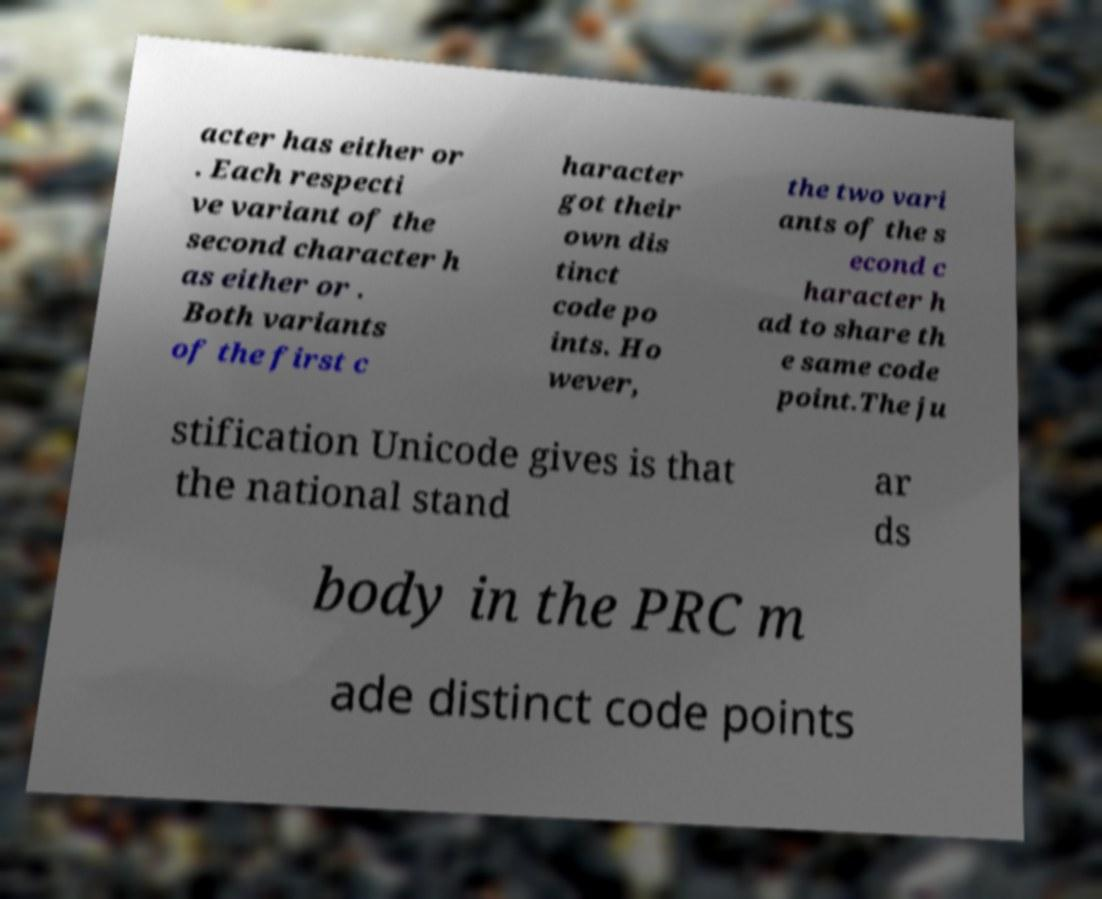Could you assist in decoding the text presented in this image and type it out clearly? acter has either or . Each respecti ve variant of the second character h as either or . Both variants of the first c haracter got their own dis tinct code po ints. Ho wever, the two vari ants of the s econd c haracter h ad to share th e same code point.The ju stification Unicode gives is that the national stand ar ds body in the PRC m ade distinct code points 